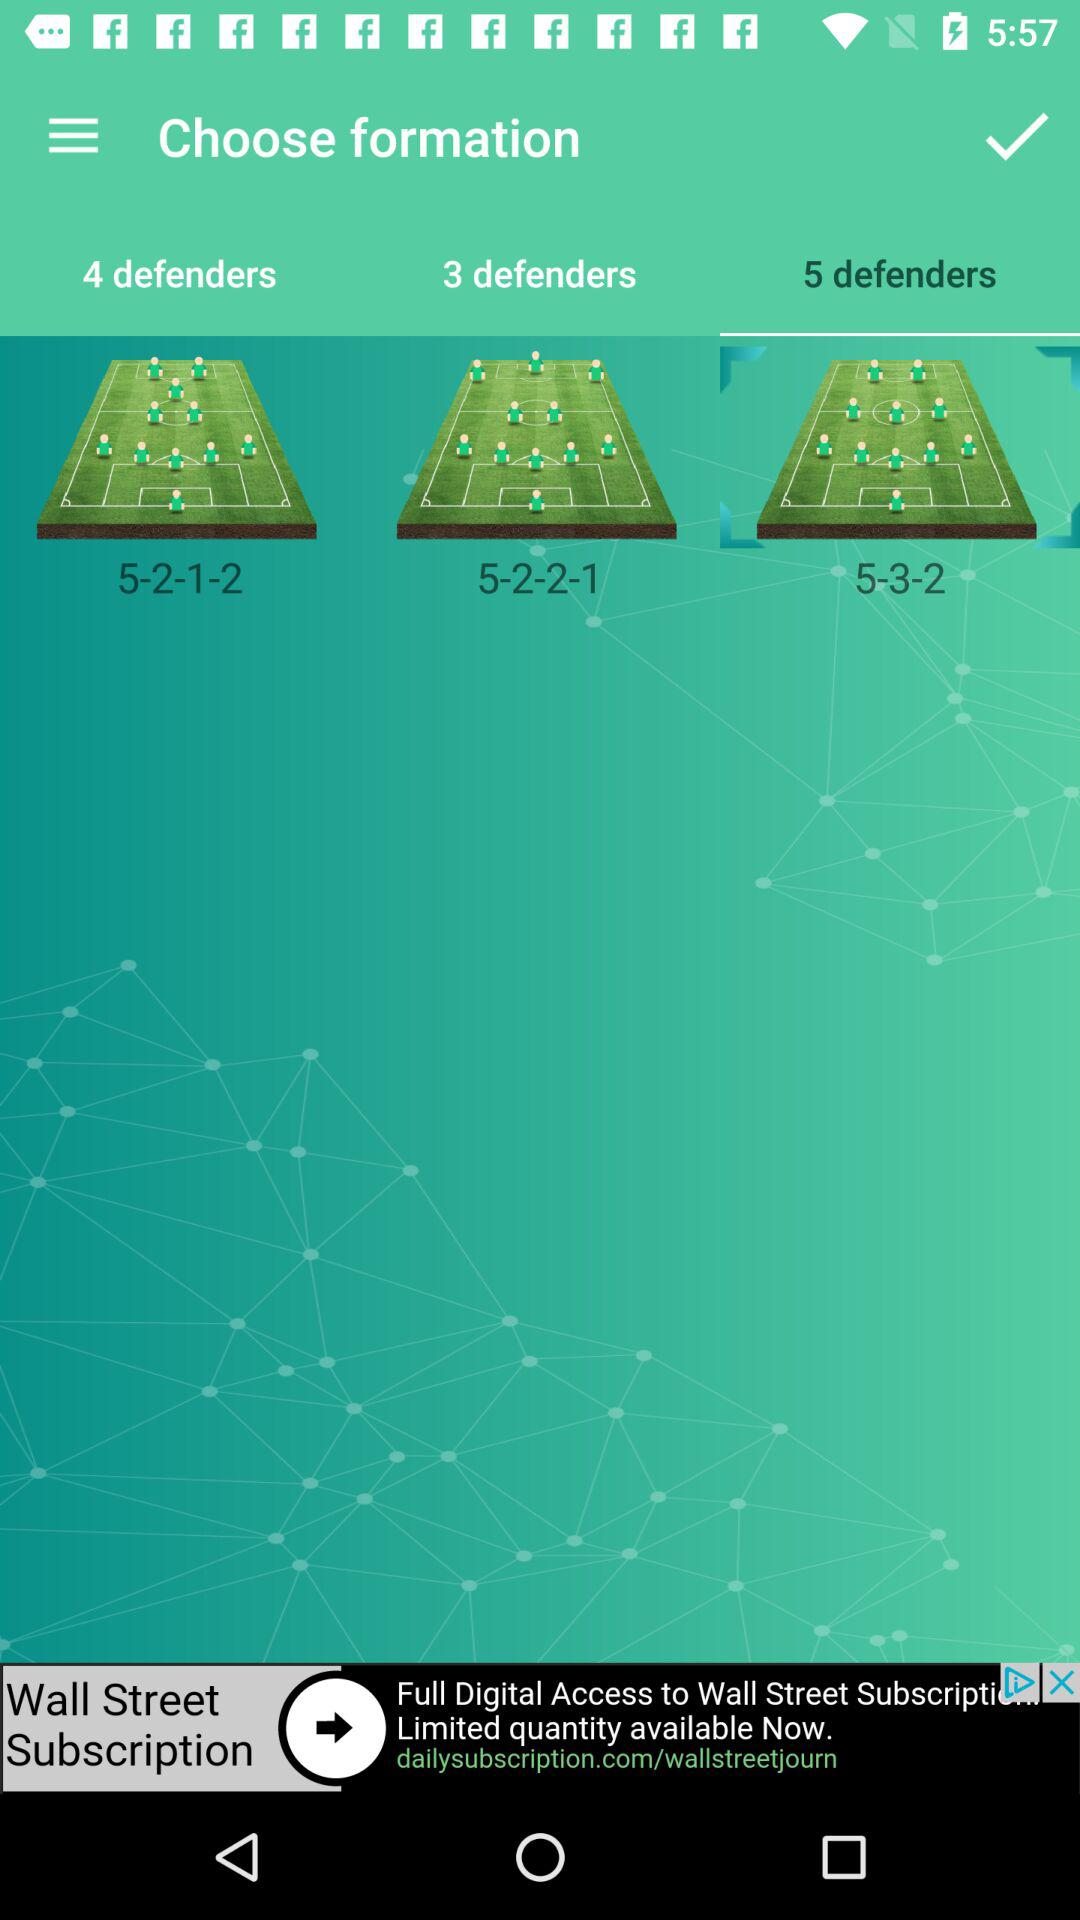How many formations are displayed on the screen?
Answer the question using a single word or phrase. 3 